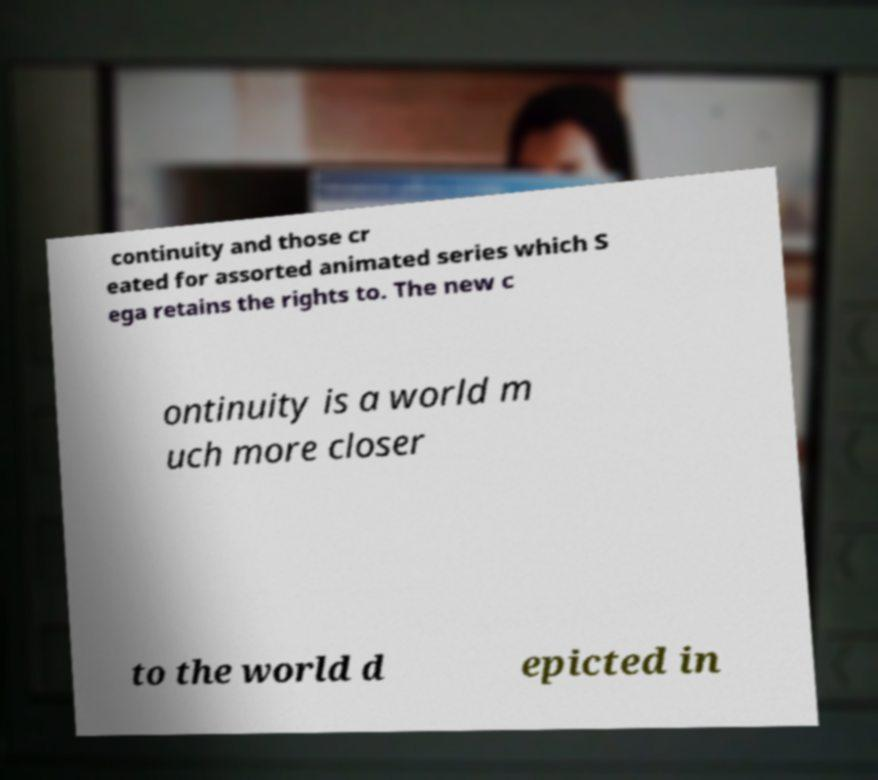What messages or text are displayed in this image? I need them in a readable, typed format. continuity and those cr eated for assorted animated series which S ega retains the rights to. The new c ontinuity is a world m uch more closer to the world d epicted in 